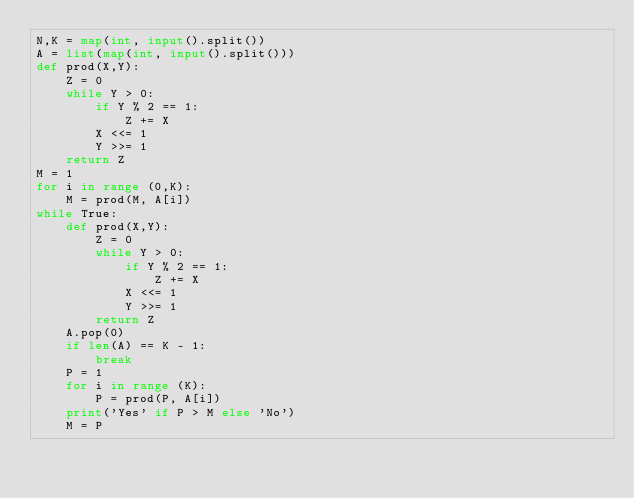<code> <loc_0><loc_0><loc_500><loc_500><_Python_>N,K = map(int, input().split())
A = list(map(int, input().split()))
def prod(X,Y):
    Z = 0
    while Y > 0:
        if Y % 2 == 1:
            Z += X
        X <<= 1
        Y >>= 1
    return Z 
M = 1
for i in range (0,K):
    M = prod(M, A[i])
while True:
    def prod(X,Y):
        Z = 0
        while Y > 0:
            if Y % 2 == 1:
                Z += X
            X <<= 1
            Y >>= 1
        return Z 
    A.pop(0)
    if len(A) == K - 1:
        break
    P = 1
    for i in range (K):
        P = prod(P, A[i])
    print('Yes' if P > M else 'No')
    M = P</code> 